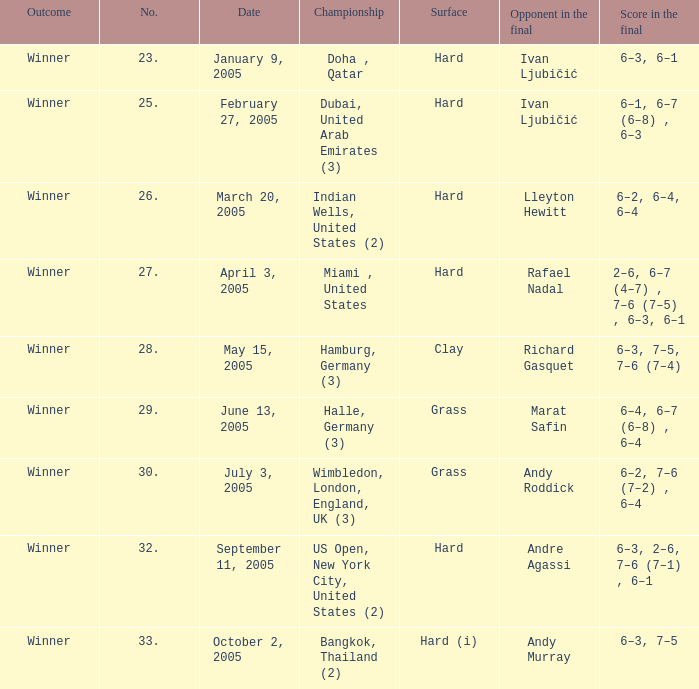What type of surface will be present in the final where andy roddick is an opponent? Grass. 